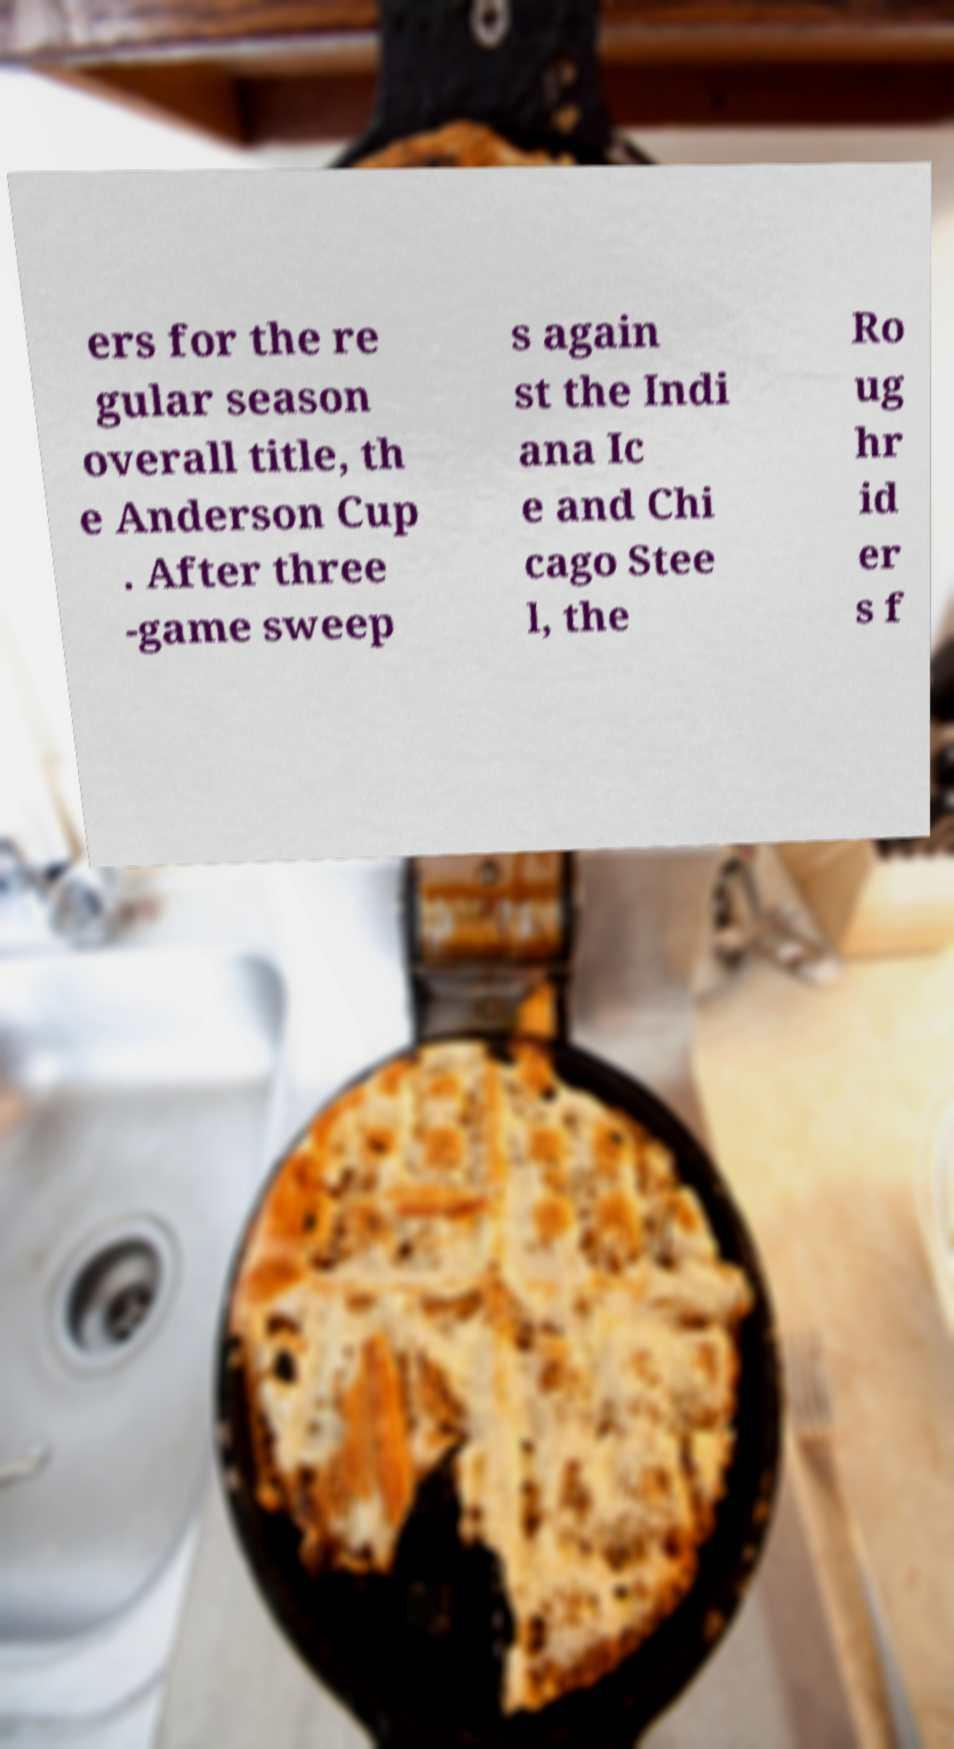Could you assist in decoding the text presented in this image and type it out clearly? ers for the re gular season overall title, th e Anderson Cup . After three -game sweep s again st the Indi ana Ic e and Chi cago Stee l, the Ro ug hr id er s f 